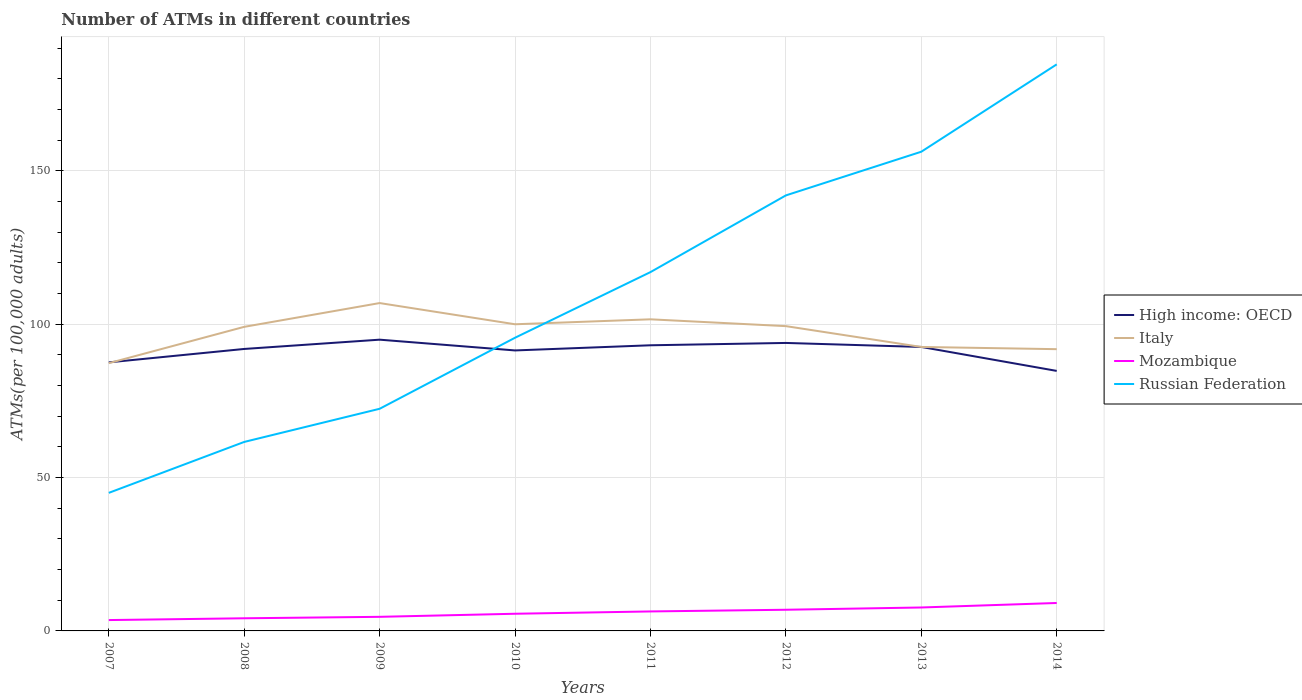Is the number of lines equal to the number of legend labels?
Offer a terse response. Yes. Across all years, what is the maximum number of ATMs in Mozambique?
Provide a succinct answer. 3.54. What is the total number of ATMs in High income: OECD in the graph?
Your response must be concise. 3.51. What is the difference between the highest and the second highest number of ATMs in High income: OECD?
Provide a succinct answer. 10.18. How many lines are there?
Provide a succinct answer. 4. How many years are there in the graph?
Provide a short and direct response. 8. What is the difference between two consecutive major ticks on the Y-axis?
Offer a terse response. 50. Does the graph contain any zero values?
Ensure brevity in your answer.  No. How are the legend labels stacked?
Offer a very short reply. Vertical. What is the title of the graph?
Make the answer very short. Number of ATMs in different countries. Does "Andorra" appear as one of the legend labels in the graph?
Provide a short and direct response. No. What is the label or title of the Y-axis?
Provide a short and direct response. ATMs(per 100,0 adults). What is the ATMs(per 100,000 adults) in High income: OECD in 2007?
Provide a short and direct response. 87.55. What is the ATMs(per 100,000 adults) in Italy in 2007?
Provide a short and direct response. 87.29. What is the ATMs(per 100,000 adults) in Mozambique in 2007?
Keep it short and to the point. 3.54. What is the ATMs(per 100,000 adults) in Russian Federation in 2007?
Provide a short and direct response. 45.01. What is the ATMs(per 100,000 adults) of High income: OECD in 2008?
Give a very brief answer. 91.92. What is the ATMs(per 100,000 adults) of Italy in 2008?
Ensure brevity in your answer.  99.13. What is the ATMs(per 100,000 adults) in Mozambique in 2008?
Your answer should be compact. 4.12. What is the ATMs(per 100,000 adults) of Russian Federation in 2008?
Keep it short and to the point. 61.61. What is the ATMs(per 100,000 adults) in High income: OECD in 2009?
Your response must be concise. 94.95. What is the ATMs(per 100,000 adults) in Italy in 2009?
Offer a very short reply. 106.88. What is the ATMs(per 100,000 adults) in Mozambique in 2009?
Make the answer very short. 4.59. What is the ATMs(per 100,000 adults) in Russian Federation in 2009?
Make the answer very short. 72.42. What is the ATMs(per 100,000 adults) of High income: OECD in 2010?
Your answer should be very brief. 91.44. What is the ATMs(per 100,000 adults) of Italy in 2010?
Keep it short and to the point. 99.97. What is the ATMs(per 100,000 adults) of Mozambique in 2010?
Offer a very short reply. 5.6. What is the ATMs(per 100,000 adults) of Russian Federation in 2010?
Keep it short and to the point. 95.58. What is the ATMs(per 100,000 adults) of High income: OECD in 2011?
Ensure brevity in your answer.  93.12. What is the ATMs(per 100,000 adults) of Italy in 2011?
Your answer should be compact. 101.58. What is the ATMs(per 100,000 adults) in Mozambique in 2011?
Your answer should be very brief. 6.35. What is the ATMs(per 100,000 adults) of Russian Federation in 2011?
Offer a terse response. 116.98. What is the ATMs(per 100,000 adults) in High income: OECD in 2012?
Provide a short and direct response. 93.88. What is the ATMs(per 100,000 adults) of Italy in 2012?
Keep it short and to the point. 99.36. What is the ATMs(per 100,000 adults) of Mozambique in 2012?
Offer a very short reply. 6.9. What is the ATMs(per 100,000 adults) in Russian Federation in 2012?
Make the answer very short. 141.98. What is the ATMs(per 100,000 adults) of High income: OECD in 2013?
Offer a very short reply. 92.57. What is the ATMs(per 100,000 adults) of Italy in 2013?
Make the answer very short. 92.57. What is the ATMs(per 100,000 adults) of Mozambique in 2013?
Offer a very short reply. 7.64. What is the ATMs(per 100,000 adults) in Russian Federation in 2013?
Give a very brief answer. 156.22. What is the ATMs(per 100,000 adults) of High income: OECD in 2014?
Your response must be concise. 84.77. What is the ATMs(per 100,000 adults) of Italy in 2014?
Your response must be concise. 91.85. What is the ATMs(per 100,000 adults) in Mozambique in 2014?
Your response must be concise. 9.11. What is the ATMs(per 100,000 adults) in Russian Federation in 2014?
Offer a very short reply. 184.7. Across all years, what is the maximum ATMs(per 100,000 adults) in High income: OECD?
Ensure brevity in your answer.  94.95. Across all years, what is the maximum ATMs(per 100,000 adults) of Italy?
Your answer should be compact. 106.88. Across all years, what is the maximum ATMs(per 100,000 adults) of Mozambique?
Give a very brief answer. 9.11. Across all years, what is the maximum ATMs(per 100,000 adults) of Russian Federation?
Your answer should be very brief. 184.7. Across all years, what is the minimum ATMs(per 100,000 adults) of High income: OECD?
Keep it short and to the point. 84.77. Across all years, what is the minimum ATMs(per 100,000 adults) in Italy?
Offer a very short reply. 87.29. Across all years, what is the minimum ATMs(per 100,000 adults) in Mozambique?
Ensure brevity in your answer.  3.54. Across all years, what is the minimum ATMs(per 100,000 adults) in Russian Federation?
Provide a succinct answer. 45.01. What is the total ATMs(per 100,000 adults) in High income: OECD in the graph?
Your answer should be very brief. 730.19. What is the total ATMs(per 100,000 adults) in Italy in the graph?
Provide a short and direct response. 778.64. What is the total ATMs(per 100,000 adults) of Mozambique in the graph?
Provide a succinct answer. 47.85. What is the total ATMs(per 100,000 adults) in Russian Federation in the graph?
Your answer should be compact. 874.48. What is the difference between the ATMs(per 100,000 adults) of High income: OECD in 2007 and that in 2008?
Offer a terse response. -4.37. What is the difference between the ATMs(per 100,000 adults) in Italy in 2007 and that in 2008?
Provide a short and direct response. -11.84. What is the difference between the ATMs(per 100,000 adults) of Mozambique in 2007 and that in 2008?
Provide a succinct answer. -0.58. What is the difference between the ATMs(per 100,000 adults) in Russian Federation in 2007 and that in 2008?
Keep it short and to the point. -16.61. What is the difference between the ATMs(per 100,000 adults) in High income: OECD in 2007 and that in 2009?
Provide a short and direct response. -7.4. What is the difference between the ATMs(per 100,000 adults) of Italy in 2007 and that in 2009?
Ensure brevity in your answer.  -19.59. What is the difference between the ATMs(per 100,000 adults) in Mozambique in 2007 and that in 2009?
Keep it short and to the point. -1.05. What is the difference between the ATMs(per 100,000 adults) of Russian Federation in 2007 and that in 2009?
Provide a succinct answer. -27.41. What is the difference between the ATMs(per 100,000 adults) in High income: OECD in 2007 and that in 2010?
Your response must be concise. -3.89. What is the difference between the ATMs(per 100,000 adults) in Italy in 2007 and that in 2010?
Your answer should be compact. -12.68. What is the difference between the ATMs(per 100,000 adults) in Mozambique in 2007 and that in 2010?
Offer a very short reply. -2.06. What is the difference between the ATMs(per 100,000 adults) of Russian Federation in 2007 and that in 2010?
Keep it short and to the point. -50.57. What is the difference between the ATMs(per 100,000 adults) in High income: OECD in 2007 and that in 2011?
Give a very brief answer. -5.57. What is the difference between the ATMs(per 100,000 adults) in Italy in 2007 and that in 2011?
Your response must be concise. -14.29. What is the difference between the ATMs(per 100,000 adults) of Mozambique in 2007 and that in 2011?
Offer a very short reply. -2.81. What is the difference between the ATMs(per 100,000 adults) of Russian Federation in 2007 and that in 2011?
Provide a succinct answer. -71.97. What is the difference between the ATMs(per 100,000 adults) in High income: OECD in 2007 and that in 2012?
Give a very brief answer. -6.34. What is the difference between the ATMs(per 100,000 adults) in Italy in 2007 and that in 2012?
Provide a short and direct response. -12.07. What is the difference between the ATMs(per 100,000 adults) in Mozambique in 2007 and that in 2012?
Keep it short and to the point. -3.36. What is the difference between the ATMs(per 100,000 adults) of Russian Federation in 2007 and that in 2012?
Keep it short and to the point. -96.98. What is the difference between the ATMs(per 100,000 adults) of High income: OECD in 2007 and that in 2013?
Give a very brief answer. -5.03. What is the difference between the ATMs(per 100,000 adults) of Italy in 2007 and that in 2013?
Provide a succinct answer. -5.28. What is the difference between the ATMs(per 100,000 adults) of Mozambique in 2007 and that in 2013?
Offer a terse response. -4.1. What is the difference between the ATMs(per 100,000 adults) in Russian Federation in 2007 and that in 2013?
Keep it short and to the point. -111.21. What is the difference between the ATMs(per 100,000 adults) of High income: OECD in 2007 and that in 2014?
Give a very brief answer. 2.78. What is the difference between the ATMs(per 100,000 adults) of Italy in 2007 and that in 2014?
Provide a succinct answer. -4.56. What is the difference between the ATMs(per 100,000 adults) in Mozambique in 2007 and that in 2014?
Give a very brief answer. -5.57. What is the difference between the ATMs(per 100,000 adults) of Russian Federation in 2007 and that in 2014?
Your response must be concise. -139.69. What is the difference between the ATMs(per 100,000 adults) of High income: OECD in 2008 and that in 2009?
Your answer should be compact. -3.03. What is the difference between the ATMs(per 100,000 adults) of Italy in 2008 and that in 2009?
Make the answer very short. -7.75. What is the difference between the ATMs(per 100,000 adults) of Mozambique in 2008 and that in 2009?
Make the answer very short. -0.47. What is the difference between the ATMs(per 100,000 adults) in Russian Federation in 2008 and that in 2009?
Your response must be concise. -10.81. What is the difference between the ATMs(per 100,000 adults) of High income: OECD in 2008 and that in 2010?
Provide a short and direct response. 0.48. What is the difference between the ATMs(per 100,000 adults) of Italy in 2008 and that in 2010?
Make the answer very short. -0.84. What is the difference between the ATMs(per 100,000 adults) in Mozambique in 2008 and that in 2010?
Your response must be concise. -1.47. What is the difference between the ATMs(per 100,000 adults) in Russian Federation in 2008 and that in 2010?
Offer a terse response. -33.97. What is the difference between the ATMs(per 100,000 adults) in High income: OECD in 2008 and that in 2011?
Provide a short and direct response. -1.2. What is the difference between the ATMs(per 100,000 adults) of Italy in 2008 and that in 2011?
Offer a very short reply. -2.46. What is the difference between the ATMs(per 100,000 adults) of Mozambique in 2008 and that in 2011?
Your answer should be very brief. -2.23. What is the difference between the ATMs(per 100,000 adults) in Russian Federation in 2008 and that in 2011?
Provide a short and direct response. -55.36. What is the difference between the ATMs(per 100,000 adults) of High income: OECD in 2008 and that in 2012?
Keep it short and to the point. -1.96. What is the difference between the ATMs(per 100,000 adults) of Italy in 2008 and that in 2012?
Ensure brevity in your answer.  -0.23. What is the difference between the ATMs(per 100,000 adults) of Mozambique in 2008 and that in 2012?
Keep it short and to the point. -2.78. What is the difference between the ATMs(per 100,000 adults) in Russian Federation in 2008 and that in 2012?
Provide a short and direct response. -80.37. What is the difference between the ATMs(per 100,000 adults) in High income: OECD in 2008 and that in 2013?
Keep it short and to the point. -0.65. What is the difference between the ATMs(per 100,000 adults) in Italy in 2008 and that in 2013?
Your response must be concise. 6.55. What is the difference between the ATMs(per 100,000 adults) in Mozambique in 2008 and that in 2013?
Provide a succinct answer. -3.52. What is the difference between the ATMs(per 100,000 adults) in Russian Federation in 2008 and that in 2013?
Provide a succinct answer. -94.61. What is the difference between the ATMs(per 100,000 adults) in High income: OECD in 2008 and that in 2014?
Give a very brief answer. 7.16. What is the difference between the ATMs(per 100,000 adults) in Italy in 2008 and that in 2014?
Ensure brevity in your answer.  7.28. What is the difference between the ATMs(per 100,000 adults) in Mozambique in 2008 and that in 2014?
Give a very brief answer. -4.99. What is the difference between the ATMs(per 100,000 adults) in Russian Federation in 2008 and that in 2014?
Your response must be concise. -123.09. What is the difference between the ATMs(per 100,000 adults) of High income: OECD in 2009 and that in 2010?
Provide a succinct answer. 3.51. What is the difference between the ATMs(per 100,000 adults) of Italy in 2009 and that in 2010?
Your answer should be compact. 6.91. What is the difference between the ATMs(per 100,000 adults) in Mozambique in 2009 and that in 2010?
Provide a short and direct response. -1. What is the difference between the ATMs(per 100,000 adults) of Russian Federation in 2009 and that in 2010?
Provide a succinct answer. -23.16. What is the difference between the ATMs(per 100,000 adults) in High income: OECD in 2009 and that in 2011?
Ensure brevity in your answer.  1.83. What is the difference between the ATMs(per 100,000 adults) in Italy in 2009 and that in 2011?
Ensure brevity in your answer.  5.3. What is the difference between the ATMs(per 100,000 adults) of Mozambique in 2009 and that in 2011?
Ensure brevity in your answer.  -1.76. What is the difference between the ATMs(per 100,000 adults) of Russian Federation in 2009 and that in 2011?
Offer a very short reply. -44.56. What is the difference between the ATMs(per 100,000 adults) of High income: OECD in 2009 and that in 2012?
Give a very brief answer. 1.06. What is the difference between the ATMs(per 100,000 adults) in Italy in 2009 and that in 2012?
Your answer should be very brief. 7.52. What is the difference between the ATMs(per 100,000 adults) in Mozambique in 2009 and that in 2012?
Keep it short and to the point. -2.31. What is the difference between the ATMs(per 100,000 adults) in Russian Federation in 2009 and that in 2012?
Keep it short and to the point. -69.56. What is the difference between the ATMs(per 100,000 adults) of High income: OECD in 2009 and that in 2013?
Make the answer very short. 2.37. What is the difference between the ATMs(per 100,000 adults) of Italy in 2009 and that in 2013?
Your answer should be compact. 14.31. What is the difference between the ATMs(per 100,000 adults) in Mozambique in 2009 and that in 2013?
Your answer should be very brief. -3.05. What is the difference between the ATMs(per 100,000 adults) in Russian Federation in 2009 and that in 2013?
Provide a short and direct response. -83.8. What is the difference between the ATMs(per 100,000 adults) of High income: OECD in 2009 and that in 2014?
Your answer should be very brief. 10.18. What is the difference between the ATMs(per 100,000 adults) of Italy in 2009 and that in 2014?
Provide a succinct answer. 15.03. What is the difference between the ATMs(per 100,000 adults) of Mozambique in 2009 and that in 2014?
Keep it short and to the point. -4.51. What is the difference between the ATMs(per 100,000 adults) in Russian Federation in 2009 and that in 2014?
Offer a very short reply. -112.28. What is the difference between the ATMs(per 100,000 adults) of High income: OECD in 2010 and that in 2011?
Your answer should be compact. -1.68. What is the difference between the ATMs(per 100,000 adults) in Italy in 2010 and that in 2011?
Give a very brief answer. -1.62. What is the difference between the ATMs(per 100,000 adults) in Mozambique in 2010 and that in 2011?
Make the answer very short. -0.76. What is the difference between the ATMs(per 100,000 adults) of Russian Federation in 2010 and that in 2011?
Offer a very short reply. -21.4. What is the difference between the ATMs(per 100,000 adults) of High income: OECD in 2010 and that in 2012?
Make the answer very short. -2.45. What is the difference between the ATMs(per 100,000 adults) in Italy in 2010 and that in 2012?
Provide a short and direct response. 0.61. What is the difference between the ATMs(per 100,000 adults) in Mozambique in 2010 and that in 2012?
Your answer should be very brief. -1.31. What is the difference between the ATMs(per 100,000 adults) of Russian Federation in 2010 and that in 2012?
Keep it short and to the point. -46.4. What is the difference between the ATMs(per 100,000 adults) of High income: OECD in 2010 and that in 2013?
Ensure brevity in your answer.  -1.14. What is the difference between the ATMs(per 100,000 adults) of Italy in 2010 and that in 2013?
Make the answer very short. 7.39. What is the difference between the ATMs(per 100,000 adults) in Mozambique in 2010 and that in 2013?
Your answer should be very brief. -2.04. What is the difference between the ATMs(per 100,000 adults) of Russian Federation in 2010 and that in 2013?
Your answer should be very brief. -60.64. What is the difference between the ATMs(per 100,000 adults) of High income: OECD in 2010 and that in 2014?
Offer a terse response. 6.67. What is the difference between the ATMs(per 100,000 adults) in Italy in 2010 and that in 2014?
Give a very brief answer. 8.12. What is the difference between the ATMs(per 100,000 adults) of Mozambique in 2010 and that in 2014?
Give a very brief answer. -3.51. What is the difference between the ATMs(per 100,000 adults) in Russian Federation in 2010 and that in 2014?
Your answer should be very brief. -89.12. What is the difference between the ATMs(per 100,000 adults) of High income: OECD in 2011 and that in 2012?
Your answer should be compact. -0.77. What is the difference between the ATMs(per 100,000 adults) in Italy in 2011 and that in 2012?
Provide a succinct answer. 2.23. What is the difference between the ATMs(per 100,000 adults) in Mozambique in 2011 and that in 2012?
Make the answer very short. -0.55. What is the difference between the ATMs(per 100,000 adults) in Russian Federation in 2011 and that in 2012?
Your answer should be very brief. -25.01. What is the difference between the ATMs(per 100,000 adults) in High income: OECD in 2011 and that in 2013?
Ensure brevity in your answer.  0.54. What is the difference between the ATMs(per 100,000 adults) of Italy in 2011 and that in 2013?
Keep it short and to the point. 9.01. What is the difference between the ATMs(per 100,000 adults) in Mozambique in 2011 and that in 2013?
Ensure brevity in your answer.  -1.29. What is the difference between the ATMs(per 100,000 adults) of Russian Federation in 2011 and that in 2013?
Your answer should be very brief. -39.24. What is the difference between the ATMs(per 100,000 adults) in High income: OECD in 2011 and that in 2014?
Your response must be concise. 8.35. What is the difference between the ATMs(per 100,000 adults) in Italy in 2011 and that in 2014?
Provide a succinct answer. 9.73. What is the difference between the ATMs(per 100,000 adults) of Mozambique in 2011 and that in 2014?
Provide a short and direct response. -2.75. What is the difference between the ATMs(per 100,000 adults) in Russian Federation in 2011 and that in 2014?
Ensure brevity in your answer.  -67.72. What is the difference between the ATMs(per 100,000 adults) of High income: OECD in 2012 and that in 2013?
Provide a short and direct response. 1.31. What is the difference between the ATMs(per 100,000 adults) in Italy in 2012 and that in 2013?
Give a very brief answer. 6.79. What is the difference between the ATMs(per 100,000 adults) in Mozambique in 2012 and that in 2013?
Give a very brief answer. -0.74. What is the difference between the ATMs(per 100,000 adults) of Russian Federation in 2012 and that in 2013?
Make the answer very short. -14.24. What is the difference between the ATMs(per 100,000 adults) in High income: OECD in 2012 and that in 2014?
Your answer should be very brief. 9.12. What is the difference between the ATMs(per 100,000 adults) of Italy in 2012 and that in 2014?
Offer a very short reply. 7.51. What is the difference between the ATMs(per 100,000 adults) of Mozambique in 2012 and that in 2014?
Provide a short and direct response. -2.21. What is the difference between the ATMs(per 100,000 adults) of Russian Federation in 2012 and that in 2014?
Keep it short and to the point. -42.72. What is the difference between the ATMs(per 100,000 adults) in High income: OECD in 2013 and that in 2014?
Your answer should be compact. 7.81. What is the difference between the ATMs(per 100,000 adults) in Italy in 2013 and that in 2014?
Your answer should be very brief. 0.72. What is the difference between the ATMs(per 100,000 adults) of Mozambique in 2013 and that in 2014?
Provide a succinct answer. -1.47. What is the difference between the ATMs(per 100,000 adults) of Russian Federation in 2013 and that in 2014?
Your response must be concise. -28.48. What is the difference between the ATMs(per 100,000 adults) of High income: OECD in 2007 and the ATMs(per 100,000 adults) of Italy in 2008?
Your answer should be compact. -11.58. What is the difference between the ATMs(per 100,000 adults) of High income: OECD in 2007 and the ATMs(per 100,000 adults) of Mozambique in 2008?
Your answer should be very brief. 83.43. What is the difference between the ATMs(per 100,000 adults) in High income: OECD in 2007 and the ATMs(per 100,000 adults) in Russian Federation in 2008?
Provide a short and direct response. 25.94. What is the difference between the ATMs(per 100,000 adults) in Italy in 2007 and the ATMs(per 100,000 adults) in Mozambique in 2008?
Provide a short and direct response. 83.17. What is the difference between the ATMs(per 100,000 adults) in Italy in 2007 and the ATMs(per 100,000 adults) in Russian Federation in 2008?
Provide a short and direct response. 25.68. What is the difference between the ATMs(per 100,000 adults) in Mozambique in 2007 and the ATMs(per 100,000 adults) in Russian Federation in 2008?
Your response must be concise. -58.07. What is the difference between the ATMs(per 100,000 adults) in High income: OECD in 2007 and the ATMs(per 100,000 adults) in Italy in 2009?
Offer a very short reply. -19.33. What is the difference between the ATMs(per 100,000 adults) of High income: OECD in 2007 and the ATMs(per 100,000 adults) of Mozambique in 2009?
Your response must be concise. 82.96. What is the difference between the ATMs(per 100,000 adults) of High income: OECD in 2007 and the ATMs(per 100,000 adults) of Russian Federation in 2009?
Provide a short and direct response. 15.13. What is the difference between the ATMs(per 100,000 adults) in Italy in 2007 and the ATMs(per 100,000 adults) in Mozambique in 2009?
Provide a succinct answer. 82.7. What is the difference between the ATMs(per 100,000 adults) of Italy in 2007 and the ATMs(per 100,000 adults) of Russian Federation in 2009?
Provide a succinct answer. 14.87. What is the difference between the ATMs(per 100,000 adults) in Mozambique in 2007 and the ATMs(per 100,000 adults) in Russian Federation in 2009?
Offer a very short reply. -68.88. What is the difference between the ATMs(per 100,000 adults) in High income: OECD in 2007 and the ATMs(per 100,000 adults) in Italy in 2010?
Give a very brief answer. -12.42. What is the difference between the ATMs(per 100,000 adults) of High income: OECD in 2007 and the ATMs(per 100,000 adults) of Mozambique in 2010?
Make the answer very short. 81.95. What is the difference between the ATMs(per 100,000 adults) in High income: OECD in 2007 and the ATMs(per 100,000 adults) in Russian Federation in 2010?
Ensure brevity in your answer.  -8.03. What is the difference between the ATMs(per 100,000 adults) in Italy in 2007 and the ATMs(per 100,000 adults) in Mozambique in 2010?
Provide a short and direct response. 81.69. What is the difference between the ATMs(per 100,000 adults) in Italy in 2007 and the ATMs(per 100,000 adults) in Russian Federation in 2010?
Ensure brevity in your answer.  -8.29. What is the difference between the ATMs(per 100,000 adults) of Mozambique in 2007 and the ATMs(per 100,000 adults) of Russian Federation in 2010?
Your response must be concise. -92.04. What is the difference between the ATMs(per 100,000 adults) of High income: OECD in 2007 and the ATMs(per 100,000 adults) of Italy in 2011?
Your answer should be very brief. -14.04. What is the difference between the ATMs(per 100,000 adults) in High income: OECD in 2007 and the ATMs(per 100,000 adults) in Mozambique in 2011?
Ensure brevity in your answer.  81.2. What is the difference between the ATMs(per 100,000 adults) of High income: OECD in 2007 and the ATMs(per 100,000 adults) of Russian Federation in 2011?
Keep it short and to the point. -29.43. What is the difference between the ATMs(per 100,000 adults) of Italy in 2007 and the ATMs(per 100,000 adults) of Mozambique in 2011?
Your answer should be compact. 80.94. What is the difference between the ATMs(per 100,000 adults) of Italy in 2007 and the ATMs(per 100,000 adults) of Russian Federation in 2011?
Your response must be concise. -29.69. What is the difference between the ATMs(per 100,000 adults) of Mozambique in 2007 and the ATMs(per 100,000 adults) of Russian Federation in 2011?
Provide a succinct answer. -113.44. What is the difference between the ATMs(per 100,000 adults) in High income: OECD in 2007 and the ATMs(per 100,000 adults) in Italy in 2012?
Offer a very short reply. -11.81. What is the difference between the ATMs(per 100,000 adults) in High income: OECD in 2007 and the ATMs(per 100,000 adults) in Mozambique in 2012?
Your response must be concise. 80.65. What is the difference between the ATMs(per 100,000 adults) of High income: OECD in 2007 and the ATMs(per 100,000 adults) of Russian Federation in 2012?
Keep it short and to the point. -54.43. What is the difference between the ATMs(per 100,000 adults) in Italy in 2007 and the ATMs(per 100,000 adults) in Mozambique in 2012?
Provide a succinct answer. 80.39. What is the difference between the ATMs(per 100,000 adults) in Italy in 2007 and the ATMs(per 100,000 adults) in Russian Federation in 2012?
Provide a short and direct response. -54.69. What is the difference between the ATMs(per 100,000 adults) in Mozambique in 2007 and the ATMs(per 100,000 adults) in Russian Federation in 2012?
Your answer should be compact. -138.44. What is the difference between the ATMs(per 100,000 adults) in High income: OECD in 2007 and the ATMs(per 100,000 adults) in Italy in 2013?
Offer a very short reply. -5.03. What is the difference between the ATMs(per 100,000 adults) in High income: OECD in 2007 and the ATMs(per 100,000 adults) in Mozambique in 2013?
Provide a short and direct response. 79.91. What is the difference between the ATMs(per 100,000 adults) in High income: OECD in 2007 and the ATMs(per 100,000 adults) in Russian Federation in 2013?
Give a very brief answer. -68.67. What is the difference between the ATMs(per 100,000 adults) in Italy in 2007 and the ATMs(per 100,000 adults) in Mozambique in 2013?
Your answer should be compact. 79.65. What is the difference between the ATMs(per 100,000 adults) in Italy in 2007 and the ATMs(per 100,000 adults) in Russian Federation in 2013?
Your response must be concise. -68.93. What is the difference between the ATMs(per 100,000 adults) in Mozambique in 2007 and the ATMs(per 100,000 adults) in Russian Federation in 2013?
Make the answer very short. -152.68. What is the difference between the ATMs(per 100,000 adults) of High income: OECD in 2007 and the ATMs(per 100,000 adults) of Italy in 2014?
Offer a terse response. -4.3. What is the difference between the ATMs(per 100,000 adults) of High income: OECD in 2007 and the ATMs(per 100,000 adults) of Mozambique in 2014?
Your answer should be very brief. 78.44. What is the difference between the ATMs(per 100,000 adults) of High income: OECD in 2007 and the ATMs(per 100,000 adults) of Russian Federation in 2014?
Provide a succinct answer. -97.15. What is the difference between the ATMs(per 100,000 adults) of Italy in 2007 and the ATMs(per 100,000 adults) of Mozambique in 2014?
Make the answer very short. 78.18. What is the difference between the ATMs(per 100,000 adults) of Italy in 2007 and the ATMs(per 100,000 adults) of Russian Federation in 2014?
Ensure brevity in your answer.  -97.41. What is the difference between the ATMs(per 100,000 adults) of Mozambique in 2007 and the ATMs(per 100,000 adults) of Russian Federation in 2014?
Ensure brevity in your answer.  -181.16. What is the difference between the ATMs(per 100,000 adults) in High income: OECD in 2008 and the ATMs(per 100,000 adults) in Italy in 2009?
Provide a succinct answer. -14.96. What is the difference between the ATMs(per 100,000 adults) in High income: OECD in 2008 and the ATMs(per 100,000 adults) in Mozambique in 2009?
Your response must be concise. 87.33. What is the difference between the ATMs(per 100,000 adults) in High income: OECD in 2008 and the ATMs(per 100,000 adults) in Russian Federation in 2009?
Offer a terse response. 19.5. What is the difference between the ATMs(per 100,000 adults) of Italy in 2008 and the ATMs(per 100,000 adults) of Mozambique in 2009?
Provide a succinct answer. 94.54. What is the difference between the ATMs(per 100,000 adults) in Italy in 2008 and the ATMs(per 100,000 adults) in Russian Federation in 2009?
Provide a succinct answer. 26.71. What is the difference between the ATMs(per 100,000 adults) of Mozambique in 2008 and the ATMs(per 100,000 adults) of Russian Federation in 2009?
Ensure brevity in your answer.  -68.3. What is the difference between the ATMs(per 100,000 adults) in High income: OECD in 2008 and the ATMs(per 100,000 adults) in Italy in 2010?
Your answer should be compact. -8.05. What is the difference between the ATMs(per 100,000 adults) of High income: OECD in 2008 and the ATMs(per 100,000 adults) of Mozambique in 2010?
Your answer should be compact. 86.33. What is the difference between the ATMs(per 100,000 adults) in High income: OECD in 2008 and the ATMs(per 100,000 adults) in Russian Federation in 2010?
Your response must be concise. -3.66. What is the difference between the ATMs(per 100,000 adults) in Italy in 2008 and the ATMs(per 100,000 adults) in Mozambique in 2010?
Offer a very short reply. 93.53. What is the difference between the ATMs(per 100,000 adults) of Italy in 2008 and the ATMs(per 100,000 adults) of Russian Federation in 2010?
Offer a terse response. 3.55. What is the difference between the ATMs(per 100,000 adults) in Mozambique in 2008 and the ATMs(per 100,000 adults) in Russian Federation in 2010?
Your response must be concise. -91.46. What is the difference between the ATMs(per 100,000 adults) of High income: OECD in 2008 and the ATMs(per 100,000 adults) of Italy in 2011?
Make the answer very short. -9.66. What is the difference between the ATMs(per 100,000 adults) in High income: OECD in 2008 and the ATMs(per 100,000 adults) in Mozambique in 2011?
Your answer should be compact. 85.57. What is the difference between the ATMs(per 100,000 adults) of High income: OECD in 2008 and the ATMs(per 100,000 adults) of Russian Federation in 2011?
Your response must be concise. -25.06. What is the difference between the ATMs(per 100,000 adults) of Italy in 2008 and the ATMs(per 100,000 adults) of Mozambique in 2011?
Give a very brief answer. 92.78. What is the difference between the ATMs(per 100,000 adults) in Italy in 2008 and the ATMs(per 100,000 adults) in Russian Federation in 2011?
Make the answer very short. -17.85. What is the difference between the ATMs(per 100,000 adults) in Mozambique in 2008 and the ATMs(per 100,000 adults) in Russian Federation in 2011?
Provide a succinct answer. -112.86. What is the difference between the ATMs(per 100,000 adults) of High income: OECD in 2008 and the ATMs(per 100,000 adults) of Italy in 2012?
Offer a terse response. -7.44. What is the difference between the ATMs(per 100,000 adults) in High income: OECD in 2008 and the ATMs(per 100,000 adults) in Mozambique in 2012?
Ensure brevity in your answer.  85.02. What is the difference between the ATMs(per 100,000 adults) of High income: OECD in 2008 and the ATMs(per 100,000 adults) of Russian Federation in 2012?
Offer a very short reply. -50.06. What is the difference between the ATMs(per 100,000 adults) of Italy in 2008 and the ATMs(per 100,000 adults) of Mozambique in 2012?
Provide a short and direct response. 92.23. What is the difference between the ATMs(per 100,000 adults) in Italy in 2008 and the ATMs(per 100,000 adults) in Russian Federation in 2012?
Offer a very short reply. -42.85. What is the difference between the ATMs(per 100,000 adults) of Mozambique in 2008 and the ATMs(per 100,000 adults) of Russian Federation in 2012?
Your response must be concise. -137.86. What is the difference between the ATMs(per 100,000 adults) in High income: OECD in 2008 and the ATMs(per 100,000 adults) in Italy in 2013?
Offer a very short reply. -0.65. What is the difference between the ATMs(per 100,000 adults) in High income: OECD in 2008 and the ATMs(per 100,000 adults) in Mozambique in 2013?
Provide a short and direct response. 84.28. What is the difference between the ATMs(per 100,000 adults) of High income: OECD in 2008 and the ATMs(per 100,000 adults) of Russian Federation in 2013?
Your response must be concise. -64.3. What is the difference between the ATMs(per 100,000 adults) in Italy in 2008 and the ATMs(per 100,000 adults) in Mozambique in 2013?
Ensure brevity in your answer.  91.49. What is the difference between the ATMs(per 100,000 adults) of Italy in 2008 and the ATMs(per 100,000 adults) of Russian Federation in 2013?
Give a very brief answer. -57.09. What is the difference between the ATMs(per 100,000 adults) of Mozambique in 2008 and the ATMs(per 100,000 adults) of Russian Federation in 2013?
Offer a terse response. -152.1. What is the difference between the ATMs(per 100,000 adults) in High income: OECD in 2008 and the ATMs(per 100,000 adults) in Italy in 2014?
Provide a short and direct response. 0.07. What is the difference between the ATMs(per 100,000 adults) in High income: OECD in 2008 and the ATMs(per 100,000 adults) in Mozambique in 2014?
Your answer should be very brief. 82.81. What is the difference between the ATMs(per 100,000 adults) of High income: OECD in 2008 and the ATMs(per 100,000 adults) of Russian Federation in 2014?
Your answer should be compact. -92.78. What is the difference between the ATMs(per 100,000 adults) of Italy in 2008 and the ATMs(per 100,000 adults) of Mozambique in 2014?
Your answer should be compact. 90.02. What is the difference between the ATMs(per 100,000 adults) of Italy in 2008 and the ATMs(per 100,000 adults) of Russian Federation in 2014?
Give a very brief answer. -85.57. What is the difference between the ATMs(per 100,000 adults) in Mozambique in 2008 and the ATMs(per 100,000 adults) in Russian Federation in 2014?
Provide a succinct answer. -180.58. What is the difference between the ATMs(per 100,000 adults) in High income: OECD in 2009 and the ATMs(per 100,000 adults) in Italy in 2010?
Provide a short and direct response. -5.02. What is the difference between the ATMs(per 100,000 adults) in High income: OECD in 2009 and the ATMs(per 100,000 adults) in Mozambique in 2010?
Offer a very short reply. 89.35. What is the difference between the ATMs(per 100,000 adults) in High income: OECD in 2009 and the ATMs(per 100,000 adults) in Russian Federation in 2010?
Offer a terse response. -0.63. What is the difference between the ATMs(per 100,000 adults) of Italy in 2009 and the ATMs(per 100,000 adults) of Mozambique in 2010?
Give a very brief answer. 101.28. What is the difference between the ATMs(per 100,000 adults) in Italy in 2009 and the ATMs(per 100,000 adults) in Russian Federation in 2010?
Provide a short and direct response. 11.3. What is the difference between the ATMs(per 100,000 adults) in Mozambique in 2009 and the ATMs(per 100,000 adults) in Russian Federation in 2010?
Provide a short and direct response. -90.99. What is the difference between the ATMs(per 100,000 adults) in High income: OECD in 2009 and the ATMs(per 100,000 adults) in Italy in 2011?
Ensure brevity in your answer.  -6.64. What is the difference between the ATMs(per 100,000 adults) of High income: OECD in 2009 and the ATMs(per 100,000 adults) of Mozambique in 2011?
Offer a terse response. 88.59. What is the difference between the ATMs(per 100,000 adults) of High income: OECD in 2009 and the ATMs(per 100,000 adults) of Russian Federation in 2011?
Give a very brief answer. -22.03. What is the difference between the ATMs(per 100,000 adults) in Italy in 2009 and the ATMs(per 100,000 adults) in Mozambique in 2011?
Provide a succinct answer. 100.53. What is the difference between the ATMs(per 100,000 adults) in Italy in 2009 and the ATMs(per 100,000 adults) in Russian Federation in 2011?
Provide a short and direct response. -10.1. What is the difference between the ATMs(per 100,000 adults) in Mozambique in 2009 and the ATMs(per 100,000 adults) in Russian Federation in 2011?
Ensure brevity in your answer.  -112.38. What is the difference between the ATMs(per 100,000 adults) of High income: OECD in 2009 and the ATMs(per 100,000 adults) of Italy in 2012?
Make the answer very short. -4.41. What is the difference between the ATMs(per 100,000 adults) of High income: OECD in 2009 and the ATMs(per 100,000 adults) of Mozambique in 2012?
Your answer should be very brief. 88.04. What is the difference between the ATMs(per 100,000 adults) of High income: OECD in 2009 and the ATMs(per 100,000 adults) of Russian Federation in 2012?
Your response must be concise. -47.03. What is the difference between the ATMs(per 100,000 adults) in Italy in 2009 and the ATMs(per 100,000 adults) in Mozambique in 2012?
Make the answer very short. 99.98. What is the difference between the ATMs(per 100,000 adults) of Italy in 2009 and the ATMs(per 100,000 adults) of Russian Federation in 2012?
Your answer should be very brief. -35.1. What is the difference between the ATMs(per 100,000 adults) in Mozambique in 2009 and the ATMs(per 100,000 adults) in Russian Federation in 2012?
Keep it short and to the point. -137.39. What is the difference between the ATMs(per 100,000 adults) of High income: OECD in 2009 and the ATMs(per 100,000 adults) of Italy in 2013?
Provide a succinct answer. 2.37. What is the difference between the ATMs(per 100,000 adults) of High income: OECD in 2009 and the ATMs(per 100,000 adults) of Mozambique in 2013?
Offer a terse response. 87.31. What is the difference between the ATMs(per 100,000 adults) of High income: OECD in 2009 and the ATMs(per 100,000 adults) of Russian Federation in 2013?
Make the answer very short. -61.27. What is the difference between the ATMs(per 100,000 adults) in Italy in 2009 and the ATMs(per 100,000 adults) in Mozambique in 2013?
Provide a short and direct response. 99.24. What is the difference between the ATMs(per 100,000 adults) in Italy in 2009 and the ATMs(per 100,000 adults) in Russian Federation in 2013?
Offer a very short reply. -49.34. What is the difference between the ATMs(per 100,000 adults) of Mozambique in 2009 and the ATMs(per 100,000 adults) of Russian Federation in 2013?
Your answer should be compact. -151.63. What is the difference between the ATMs(per 100,000 adults) in High income: OECD in 2009 and the ATMs(per 100,000 adults) in Italy in 2014?
Provide a short and direct response. 3.1. What is the difference between the ATMs(per 100,000 adults) in High income: OECD in 2009 and the ATMs(per 100,000 adults) in Mozambique in 2014?
Make the answer very short. 85.84. What is the difference between the ATMs(per 100,000 adults) of High income: OECD in 2009 and the ATMs(per 100,000 adults) of Russian Federation in 2014?
Offer a very short reply. -89.75. What is the difference between the ATMs(per 100,000 adults) of Italy in 2009 and the ATMs(per 100,000 adults) of Mozambique in 2014?
Provide a short and direct response. 97.77. What is the difference between the ATMs(per 100,000 adults) of Italy in 2009 and the ATMs(per 100,000 adults) of Russian Federation in 2014?
Your answer should be compact. -77.82. What is the difference between the ATMs(per 100,000 adults) of Mozambique in 2009 and the ATMs(per 100,000 adults) of Russian Federation in 2014?
Offer a very short reply. -180.11. What is the difference between the ATMs(per 100,000 adults) of High income: OECD in 2010 and the ATMs(per 100,000 adults) of Italy in 2011?
Your answer should be compact. -10.15. What is the difference between the ATMs(per 100,000 adults) of High income: OECD in 2010 and the ATMs(per 100,000 adults) of Mozambique in 2011?
Your response must be concise. 85.08. What is the difference between the ATMs(per 100,000 adults) in High income: OECD in 2010 and the ATMs(per 100,000 adults) in Russian Federation in 2011?
Your response must be concise. -25.54. What is the difference between the ATMs(per 100,000 adults) in Italy in 2010 and the ATMs(per 100,000 adults) in Mozambique in 2011?
Your response must be concise. 93.62. What is the difference between the ATMs(per 100,000 adults) of Italy in 2010 and the ATMs(per 100,000 adults) of Russian Federation in 2011?
Offer a terse response. -17.01. What is the difference between the ATMs(per 100,000 adults) of Mozambique in 2010 and the ATMs(per 100,000 adults) of Russian Federation in 2011?
Offer a terse response. -111.38. What is the difference between the ATMs(per 100,000 adults) in High income: OECD in 2010 and the ATMs(per 100,000 adults) in Italy in 2012?
Make the answer very short. -7.92. What is the difference between the ATMs(per 100,000 adults) of High income: OECD in 2010 and the ATMs(per 100,000 adults) of Mozambique in 2012?
Offer a terse response. 84.54. What is the difference between the ATMs(per 100,000 adults) in High income: OECD in 2010 and the ATMs(per 100,000 adults) in Russian Federation in 2012?
Keep it short and to the point. -50.54. What is the difference between the ATMs(per 100,000 adults) in Italy in 2010 and the ATMs(per 100,000 adults) in Mozambique in 2012?
Keep it short and to the point. 93.07. What is the difference between the ATMs(per 100,000 adults) in Italy in 2010 and the ATMs(per 100,000 adults) in Russian Federation in 2012?
Provide a succinct answer. -42.01. What is the difference between the ATMs(per 100,000 adults) in Mozambique in 2010 and the ATMs(per 100,000 adults) in Russian Federation in 2012?
Ensure brevity in your answer.  -136.39. What is the difference between the ATMs(per 100,000 adults) of High income: OECD in 2010 and the ATMs(per 100,000 adults) of Italy in 2013?
Provide a succinct answer. -1.14. What is the difference between the ATMs(per 100,000 adults) of High income: OECD in 2010 and the ATMs(per 100,000 adults) of Mozambique in 2013?
Offer a very short reply. 83.8. What is the difference between the ATMs(per 100,000 adults) of High income: OECD in 2010 and the ATMs(per 100,000 adults) of Russian Federation in 2013?
Ensure brevity in your answer.  -64.78. What is the difference between the ATMs(per 100,000 adults) in Italy in 2010 and the ATMs(per 100,000 adults) in Mozambique in 2013?
Ensure brevity in your answer.  92.33. What is the difference between the ATMs(per 100,000 adults) of Italy in 2010 and the ATMs(per 100,000 adults) of Russian Federation in 2013?
Your answer should be very brief. -56.25. What is the difference between the ATMs(per 100,000 adults) in Mozambique in 2010 and the ATMs(per 100,000 adults) in Russian Federation in 2013?
Offer a terse response. -150.62. What is the difference between the ATMs(per 100,000 adults) in High income: OECD in 2010 and the ATMs(per 100,000 adults) in Italy in 2014?
Your response must be concise. -0.41. What is the difference between the ATMs(per 100,000 adults) of High income: OECD in 2010 and the ATMs(per 100,000 adults) of Mozambique in 2014?
Offer a terse response. 82.33. What is the difference between the ATMs(per 100,000 adults) of High income: OECD in 2010 and the ATMs(per 100,000 adults) of Russian Federation in 2014?
Ensure brevity in your answer.  -93.26. What is the difference between the ATMs(per 100,000 adults) of Italy in 2010 and the ATMs(per 100,000 adults) of Mozambique in 2014?
Provide a succinct answer. 90.86. What is the difference between the ATMs(per 100,000 adults) of Italy in 2010 and the ATMs(per 100,000 adults) of Russian Federation in 2014?
Provide a short and direct response. -84.73. What is the difference between the ATMs(per 100,000 adults) in Mozambique in 2010 and the ATMs(per 100,000 adults) in Russian Federation in 2014?
Your answer should be compact. -179.1. What is the difference between the ATMs(per 100,000 adults) in High income: OECD in 2011 and the ATMs(per 100,000 adults) in Italy in 2012?
Keep it short and to the point. -6.24. What is the difference between the ATMs(per 100,000 adults) in High income: OECD in 2011 and the ATMs(per 100,000 adults) in Mozambique in 2012?
Ensure brevity in your answer.  86.22. What is the difference between the ATMs(per 100,000 adults) in High income: OECD in 2011 and the ATMs(per 100,000 adults) in Russian Federation in 2012?
Your answer should be very brief. -48.86. What is the difference between the ATMs(per 100,000 adults) of Italy in 2011 and the ATMs(per 100,000 adults) of Mozambique in 2012?
Keep it short and to the point. 94.68. What is the difference between the ATMs(per 100,000 adults) in Italy in 2011 and the ATMs(per 100,000 adults) in Russian Federation in 2012?
Keep it short and to the point. -40.4. What is the difference between the ATMs(per 100,000 adults) of Mozambique in 2011 and the ATMs(per 100,000 adults) of Russian Federation in 2012?
Keep it short and to the point. -135.63. What is the difference between the ATMs(per 100,000 adults) of High income: OECD in 2011 and the ATMs(per 100,000 adults) of Italy in 2013?
Keep it short and to the point. 0.54. What is the difference between the ATMs(per 100,000 adults) in High income: OECD in 2011 and the ATMs(per 100,000 adults) in Mozambique in 2013?
Provide a succinct answer. 85.48. What is the difference between the ATMs(per 100,000 adults) of High income: OECD in 2011 and the ATMs(per 100,000 adults) of Russian Federation in 2013?
Offer a terse response. -63.1. What is the difference between the ATMs(per 100,000 adults) of Italy in 2011 and the ATMs(per 100,000 adults) of Mozambique in 2013?
Provide a short and direct response. 93.94. What is the difference between the ATMs(per 100,000 adults) in Italy in 2011 and the ATMs(per 100,000 adults) in Russian Federation in 2013?
Your answer should be compact. -54.63. What is the difference between the ATMs(per 100,000 adults) in Mozambique in 2011 and the ATMs(per 100,000 adults) in Russian Federation in 2013?
Offer a terse response. -149.87. What is the difference between the ATMs(per 100,000 adults) in High income: OECD in 2011 and the ATMs(per 100,000 adults) in Italy in 2014?
Provide a short and direct response. 1.27. What is the difference between the ATMs(per 100,000 adults) in High income: OECD in 2011 and the ATMs(per 100,000 adults) in Mozambique in 2014?
Your response must be concise. 84.01. What is the difference between the ATMs(per 100,000 adults) of High income: OECD in 2011 and the ATMs(per 100,000 adults) of Russian Federation in 2014?
Provide a succinct answer. -91.58. What is the difference between the ATMs(per 100,000 adults) of Italy in 2011 and the ATMs(per 100,000 adults) of Mozambique in 2014?
Your response must be concise. 92.48. What is the difference between the ATMs(per 100,000 adults) in Italy in 2011 and the ATMs(per 100,000 adults) in Russian Federation in 2014?
Keep it short and to the point. -83.11. What is the difference between the ATMs(per 100,000 adults) of Mozambique in 2011 and the ATMs(per 100,000 adults) of Russian Federation in 2014?
Ensure brevity in your answer.  -178.34. What is the difference between the ATMs(per 100,000 adults) in High income: OECD in 2012 and the ATMs(per 100,000 adults) in Italy in 2013?
Provide a succinct answer. 1.31. What is the difference between the ATMs(per 100,000 adults) in High income: OECD in 2012 and the ATMs(per 100,000 adults) in Mozambique in 2013?
Offer a very short reply. 86.24. What is the difference between the ATMs(per 100,000 adults) of High income: OECD in 2012 and the ATMs(per 100,000 adults) of Russian Federation in 2013?
Keep it short and to the point. -62.33. What is the difference between the ATMs(per 100,000 adults) of Italy in 2012 and the ATMs(per 100,000 adults) of Mozambique in 2013?
Ensure brevity in your answer.  91.72. What is the difference between the ATMs(per 100,000 adults) of Italy in 2012 and the ATMs(per 100,000 adults) of Russian Federation in 2013?
Give a very brief answer. -56.86. What is the difference between the ATMs(per 100,000 adults) of Mozambique in 2012 and the ATMs(per 100,000 adults) of Russian Federation in 2013?
Ensure brevity in your answer.  -149.32. What is the difference between the ATMs(per 100,000 adults) in High income: OECD in 2012 and the ATMs(per 100,000 adults) in Italy in 2014?
Give a very brief answer. 2.03. What is the difference between the ATMs(per 100,000 adults) of High income: OECD in 2012 and the ATMs(per 100,000 adults) of Mozambique in 2014?
Make the answer very short. 84.78. What is the difference between the ATMs(per 100,000 adults) of High income: OECD in 2012 and the ATMs(per 100,000 adults) of Russian Federation in 2014?
Your answer should be very brief. -90.81. What is the difference between the ATMs(per 100,000 adults) of Italy in 2012 and the ATMs(per 100,000 adults) of Mozambique in 2014?
Provide a short and direct response. 90.25. What is the difference between the ATMs(per 100,000 adults) of Italy in 2012 and the ATMs(per 100,000 adults) of Russian Federation in 2014?
Make the answer very short. -85.34. What is the difference between the ATMs(per 100,000 adults) of Mozambique in 2012 and the ATMs(per 100,000 adults) of Russian Federation in 2014?
Give a very brief answer. -177.8. What is the difference between the ATMs(per 100,000 adults) in High income: OECD in 2013 and the ATMs(per 100,000 adults) in Italy in 2014?
Offer a terse response. 0.72. What is the difference between the ATMs(per 100,000 adults) in High income: OECD in 2013 and the ATMs(per 100,000 adults) in Mozambique in 2014?
Offer a very short reply. 83.47. What is the difference between the ATMs(per 100,000 adults) in High income: OECD in 2013 and the ATMs(per 100,000 adults) in Russian Federation in 2014?
Provide a succinct answer. -92.12. What is the difference between the ATMs(per 100,000 adults) in Italy in 2013 and the ATMs(per 100,000 adults) in Mozambique in 2014?
Your response must be concise. 83.47. What is the difference between the ATMs(per 100,000 adults) of Italy in 2013 and the ATMs(per 100,000 adults) of Russian Federation in 2014?
Your answer should be compact. -92.12. What is the difference between the ATMs(per 100,000 adults) in Mozambique in 2013 and the ATMs(per 100,000 adults) in Russian Federation in 2014?
Keep it short and to the point. -177.06. What is the average ATMs(per 100,000 adults) in High income: OECD per year?
Offer a terse response. 91.27. What is the average ATMs(per 100,000 adults) of Italy per year?
Your answer should be compact. 97.33. What is the average ATMs(per 100,000 adults) in Mozambique per year?
Your answer should be very brief. 5.98. What is the average ATMs(per 100,000 adults) of Russian Federation per year?
Provide a succinct answer. 109.31. In the year 2007, what is the difference between the ATMs(per 100,000 adults) in High income: OECD and ATMs(per 100,000 adults) in Italy?
Your answer should be compact. 0.26. In the year 2007, what is the difference between the ATMs(per 100,000 adults) in High income: OECD and ATMs(per 100,000 adults) in Mozambique?
Keep it short and to the point. 84.01. In the year 2007, what is the difference between the ATMs(per 100,000 adults) of High income: OECD and ATMs(per 100,000 adults) of Russian Federation?
Provide a succinct answer. 42.54. In the year 2007, what is the difference between the ATMs(per 100,000 adults) in Italy and ATMs(per 100,000 adults) in Mozambique?
Provide a succinct answer. 83.75. In the year 2007, what is the difference between the ATMs(per 100,000 adults) of Italy and ATMs(per 100,000 adults) of Russian Federation?
Provide a succinct answer. 42.28. In the year 2007, what is the difference between the ATMs(per 100,000 adults) of Mozambique and ATMs(per 100,000 adults) of Russian Federation?
Make the answer very short. -41.47. In the year 2008, what is the difference between the ATMs(per 100,000 adults) of High income: OECD and ATMs(per 100,000 adults) of Italy?
Keep it short and to the point. -7.21. In the year 2008, what is the difference between the ATMs(per 100,000 adults) in High income: OECD and ATMs(per 100,000 adults) in Mozambique?
Provide a succinct answer. 87.8. In the year 2008, what is the difference between the ATMs(per 100,000 adults) of High income: OECD and ATMs(per 100,000 adults) of Russian Federation?
Make the answer very short. 30.31. In the year 2008, what is the difference between the ATMs(per 100,000 adults) of Italy and ATMs(per 100,000 adults) of Mozambique?
Offer a terse response. 95.01. In the year 2008, what is the difference between the ATMs(per 100,000 adults) of Italy and ATMs(per 100,000 adults) of Russian Federation?
Make the answer very short. 37.52. In the year 2008, what is the difference between the ATMs(per 100,000 adults) of Mozambique and ATMs(per 100,000 adults) of Russian Federation?
Offer a very short reply. -57.49. In the year 2009, what is the difference between the ATMs(per 100,000 adults) in High income: OECD and ATMs(per 100,000 adults) in Italy?
Make the answer very short. -11.93. In the year 2009, what is the difference between the ATMs(per 100,000 adults) of High income: OECD and ATMs(per 100,000 adults) of Mozambique?
Provide a succinct answer. 90.35. In the year 2009, what is the difference between the ATMs(per 100,000 adults) in High income: OECD and ATMs(per 100,000 adults) in Russian Federation?
Make the answer very short. 22.53. In the year 2009, what is the difference between the ATMs(per 100,000 adults) in Italy and ATMs(per 100,000 adults) in Mozambique?
Ensure brevity in your answer.  102.29. In the year 2009, what is the difference between the ATMs(per 100,000 adults) of Italy and ATMs(per 100,000 adults) of Russian Federation?
Offer a terse response. 34.46. In the year 2009, what is the difference between the ATMs(per 100,000 adults) of Mozambique and ATMs(per 100,000 adults) of Russian Federation?
Your response must be concise. -67.82. In the year 2010, what is the difference between the ATMs(per 100,000 adults) in High income: OECD and ATMs(per 100,000 adults) in Italy?
Give a very brief answer. -8.53. In the year 2010, what is the difference between the ATMs(per 100,000 adults) of High income: OECD and ATMs(per 100,000 adults) of Mozambique?
Keep it short and to the point. 85.84. In the year 2010, what is the difference between the ATMs(per 100,000 adults) of High income: OECD and ATMs(per 100,000 adults) of Russian Federation?
Keep it short and to the point. -4.14. In the year 2010, what is the difference between the ATMs(per 100,000 adults) in Italy and ATMs(per 100,000 adults) in Mozambique?
Keep it short and to the point. 94.37. In the year 2010, what is the difference between the ATMs(per 100,000 adults) in Italy and ATMs(per 100,000 adults) in Russian Federation?
Your answer should be compact. 4.39. In the year 2010, what is the difference between the ATMs(per 100,000 adults) of Mozambique and ATMs(per 100,000 adults) of Russian Federation?
Your answer should be very brief. -89.98. In the year 2011, what is the difference between the ATMs(per 100,000 adults) of High income: OECD and ATMs(per 100,000 adults) of Italy?
Provide a short and direct response. -8.47. In the year 2011, what is the difference between the ATMs(per 100,000 adults) in High income: OECD and ATMs(per 100,000 adults) in Mozambique?
Your response must be concise. 86.77. In the year 2011, what is the difference between the ATMs(per 100,000 adults) of High income: OECD and ATMs(per 100,000 adults) of Russian Federation?
Give a very brief answer. -23.86. In the year 2011, what is the difference between the ATMs(per 100,000 adults) of Italy and ATMs(per 100,000 adults) of Mozambique?
Keep it short and to the point. 95.23. In the year 2011, what is the difference between the ATMs(per 100,000 adults) in Italy and ATMs(per 100,000 adults) in Russian Federation?
Make the answer very short. -15.39. In the year 2011, what is the difference between the ATMs(per 100,000 adults) in Mozambique and ATMs(per 100,000 adults) in Russian Federation?
Give a very brief answer. -110.62. In the year 2012, what is the difference between the ATMs(per 100,000 adults) in High income: OECD and ATMs(per 100,000 adults) in Italy?
Offer a very short reply. -5.48. In the year 2012, what is the difference between the ATMs(per 100,000 adults) of High income: OECD and ATMs(per 100,000 adults) of Mozambique?
Provide a short and direct response. 86.98. In the year 2012, what is the difference between the ATMs(per 100,000 adults) in High income: OECD and ATMs(per 100,000 adults) in Russian Federation?
Ensure brevity in your answer.  -48.1. In the year 2012, what is the difference between the ATMs(per 100,000 adults) of Italy and ATMs(per 100,000 adults) of Mozambique?
Provide a succinct answer. 92.46. In the year 2012, what is the difference between the ATMs(per 100,000 adults) in Italy and ATMs(per 100,000 adults) in Russian Federation?
Make the answer very short. -42.62. In the year 2012, what is the difference between the ATMs(per 100,000 adults) in Mozambique and ATMs(per 100,000 adults) in Russian Federation?
Provide a short and direct response. -135.08. In the year 2013, what is the difference between the ATMs(per 100,000 adults) of High income: OECD and ATMs(per 100,000 adults) of Italy?
Ensure brevity in your answer.  0. In the year 2013, what is the difference between the ATMs(per 100,000 adults) in High income: OECD and ATMs(per 100,000 adults) in Mozambique?
Your answer should be very brief. 84.93. In the year 2013, what is the difference between the ATMs(per 100,000 adults) in High income: OECD and ATMs(per 100,000 adults) in Russian Federation?
Your response must be concise. -63.64. In the year 2013, what is the difference between the ATMs(per 100,000 adults) in Italy and ATMs(per 100,000 adults) in Mozambique?
Your response must be concise. 84.93. In the year 2013, what is the difference between the ATMs(per 100,000 adults) in Italy and ATMs(per 100,000 adults) in Russian Federation?
Your answer should be compact. -63.64. In the year 2013, what is the difference between the ATMs(per 100,000 adults) of Mozambique and ATMs(per 100,000 adults) of Russian Federation?
Give a very brief answer. -148.58. In the year 2014, what is the difference between the ATMs(per 100,000 adults) of High income: OECD and ATMs(per 100,000 adults) of Italy?
Offer a terse response. -7.09. In the year 2014, what is the difference between the ATMs(per 100,000 adults) of High income: OECD and ATMs(per 100,000 adults) of Mozambique?
Your answer should be very brief. 75.66. In the year 2014, what is the difference between the ATMs(per 100,000 adults) of High income: OECD and ATMs(per 100,000 adults) of Russian Federation?
Give a very brief answer. -99.93. In the year 2014, what is the difference between the ATMs(per 100,000 adults) of Italy and ATMs(per 100,000 adults) of Mozambique?
Offer a very short reply. 82.74. In the year 2014, what is the difference between the ATMs(per 100,000 adults) in Italy and ATMs(per 100,000 adults) in Russian Federation?
Provide a short and direct response. -92.85. In the year 2014, what is the difference between the ATMs(per 100,000 adults) of Mozambique and ATMs(per 100,000 adults) of Russian Federation?
Your answer should be very brief. -175.59. What is the ratio of the ATMs(per 100,000 adults) in Italy in 2007 to that in 2008?
Your answer should be very brief. 0.88. What is the ratio of the ATMs(per 100,000 adults) of Mozambique in 2007 to that in 2008?
Your response must be concise. 0.86. What is the ratio of the ATMs(per 100,000 adults) in Russian Federation in 2007 to that in 2008?
Offer a terse response. 0.73. What is the ratio of the ATMs(per 100,000 adults) of High income: OECD in 2007 to that in 2009?
Keep it short and to the point. 0.92. What is the ratio of the ATMs(per 100,000 adults) in Italy in 2007 to that in 2009?
Provide a short and direct response. 0.82. What is the ratio of the ATMs(per 100,000 adults) of Mozambique in 2007 to that in 2009?
Give a very brief answer. 0.77. What is the ratio of the ATMs(per 100,000 adults) of Russian Federation in 2007 to that in 2009?
Your answer should be very brief. 0.62. What is the ratio of the ATMs(per 100,000 adults) of High income: OECD in 2007 to that in 2010?
Provide a succinct answer. 0.96. What is the ratio of the ATMs(per 100,000 adults) in Italy in 2007 to that in 2010?
Provide a succinct answer. 0.87. What is the ratio of the ATMs(per 100,000 adults) of Mozambique in 2007 to that in 2010?
Give a very brief answer. 0.63. What is the ratio of the ATMs(per 100,000 adults) of Russian Federation in 2007 to that in 2010?
Provide a succinct answer. 0.47. What is the ratio of the ATMs(per 100,000 adults) in High income: OECD in 2007 to that in 2011?
Make the answer very short. 0.94. What is the ratio of the ATMs(per 100,000 adults) of Italy in 2007 to that in 2011?
Your answer should be compact. 0.86. What is the ratio of the ATMs(per 100,000 adults) of Mozambique in 2007 to that in 2011?
Make the answer very short. 0.56. What is the ratio of the ATMs(per 100,000 adults) in Russian Federation in 2007 to that in 2011?
Offer a very short reply. 0.38. What is the ratio of the ATMs(per 100,000 adults) of High income: OECD in 2007 to that in 2012?
Your answer should be compact. 0.93. What is the ratio of the ATMs(per 100,000 adults) of Italy in 2007 to that in 2012?
Keep it short and to the point. 0.88. What is the ratio of the ATMs(per 100,000 adults) in Mozambique in 2007 to that in 2012?
Provide a short and direct response. 0.51. What is the ratio of the ATMs(per 100,000 adults) in Russian Federation in 2007 to that in 2012?
Offer a terse response. 0.32. What is the ratio of the ATMs(per 100,000 adults) in High income: OECD in 2007 to that in 2013?
Give a very brief answer. 0.95. What is the ratio of the ATMs(per 100,000 adults) of Italy in 2007 to that in 2013?
Ensure brevity in your answer.  0.94. What is the ratio of the ATMs(per 100,000 adults) of Mozambique in 2007 to that in 2013?
Offer a very short reply. 0.46. What is the ratio of the ATMs(per 100,000 adults) of Russian Federation in 2007 to that in 2013?
Ensure brevity in your answer.  0.29. What is the ratio of the ATMs(per 100,000 adults) of High income: OECD in 2007 to that in 2014?
Your answer should be very brief. 1.03. What is the ratio of the ATMs(per 100,000 adults) of Italy in 2007 to that in 2014?
Keep it short and to the point. 0.95. What is the ratio of the ATMs(per 100,000 adults) of Mozambique in 2007 to that in 2014?
Offer a terse response. 0.39. What is the ratio of the ATMs(per 100,000 adults) of Russian Federation in 2007 to that in 2014?
Ensure brevity in your answer.  0.24. What is the ratio of the ATMs(per 100,000 adults) in High income: OECD in 2008 to that in 2009?
Offer a terse response. 0.97. What is the ratio of the ATMs(per 100,000 adults) in Italy in 2008 to that in 2009?
Give a very brief answer. 0.93. What is the ratio of the ATMs(per 100,000 adults) of Mozambique in 2008 to that in 2009?
Your answer should be compact. 0.9. What is the ratio of the ATMs(per 100,000 adults) in Russian Federation in 2008 to that in 2009?
Offer a terse response. 0.85. What is the ratio of the ATMs(per 100,000 adults) in Mozambique in 2008 to that in 2010?
Give a very brief answer. 0.74. What is the ratio of the ATMs(per 100,000 adults) in Russian Federation in 2008 to that in 2010?
Make the answer very short. 0.64. What is the ratio of the ATMs(per 100,000 adults) of High income: OECD in 2008 to that in 2011?
Offer a very short reply. 0.99. What is the ratio of the ATMs(per 100,000 adults) in Italy in 2008 to that in 2011?
Give a very brief answer. 0.98. What is the ratio of the ATMs(per 100,000 adults) in Mozambique in 2008 to that in 2011?
Ensure brevity in your answer.  0.65. What is the ratio of the ATMs(per 100,000 adults) of Russian Federation in 2008 to that in 2011?
Your response must be concise. 0.53. What is the ratio of the ATMs(per 100,000 adults) in High income: OECD in 2008 to that in 2012?
Ensure brevity in your answer.  0.98. What is the ratio of the ATMs(per 100,000 adults) of Italy in 2008 to that in 2012?
Provide a short and direct response. 1. What is the ratio of the ATMs(per 100,000 adults) of Mozambique in 2008 to that in 2012?
Provide a short and direct response. 0.6. What is the ratio of the ATMs(per 100,000 adults) of Russian Federation in 2008 to that in 2012?
Offer a terse response. 0.43. What is the ratio of the ATMs(per 100,000 adults) in High income: OECD in 2008 to that in 2013?
Provide a short and direct response. 0.99. What is the ratio of the ATMs(per 100,000 adults) in Italy in 2008 to that in 2013?
Your answer should be very brief. 1.07. What is the ratio of the ATMs(per 100,000 adults) of Mozambique in 2008 to that in 2013?
Keep it short and to the point. 0.54. What is the ratio of the ATMs(per 100,000 adults) in Russian Federation in 2008 to that in 2013?
Offer a terse response. 0.39. What is the ratio of the ATMs(per 100,000 adults) of High income: OECD in 2008 to that in 2014?
Give a very brief answer. 1.08. What is the ratio of the ATMs(per 100,000 adults) in Italy in 2008 to that in 2014?
Ensure brevity in your answer.  1.08. What is the ratio of the ATMs(per 100,000 adults) of Mozambique in 2008 to that in 2014?
Give a very brief answer. 0.45. What is the ratio of the ATMs(per 100,000 adults) in Russian Federation in 2008 to that in 2014?
Offer a terse response. 0.33. What is the ratio of the ATMs(per 100,000 adults) in High income: OECD in 2009 to that in 2010?
Provide a succinct answer. 1.04. What is the ratio of the ATMs(per 100,000 adults) of Italy in 2009 to that in 2010?
Provide a short and direct response. 1.07. What is the ratio of the ATMs(per 100,000 adults) of Mozambique in 2009 to that in 2010?
Offer a terse response. 0.82. What is the ratio of the ATMs(per 100,000 adults) of Russian Federation in 2009 to that in 2010?
Provide a short and direct response. 0.76. What is the ratio of the ATMs(per 100,000 adults) of High income: OECD in 2009 to that in 2011?
Your answer should be very brief. 1.02. What is the ratio of the ATMs(per 100,000 adults) of Italy in 2009 to that in 2011?
Provide a succinct answer. 1.05. What is the ratio of the ATMs(per 100,000 adults) of Mozambique in 2009 to that in 2011?
Your answer should be very brief. 0.72. What is the ratio of the ATMs(per 100,000 adults) in Russian Federation in 2009 to that in 2011?
Your answer should be compact. 0.62. What is the ratio of the ATMs(per 100,000 adults) in High income: OECD in 2009 to that in 2012?
Your answer should be compact. 1.01. What is the ratio of the ATMs(per 100,000 adults) in Italy in 2009 to that in 2012?
Your response must be concise. 1.08. What is the ratio of the ATMs(per 100,000 adults) in Mozambique in 2009 to that in 2012?
Ensure brevity in your answer.  0.67. What is the ratio of the ATMs(per 100,000 adults) in Russian Federation in 2009 to that in 2012?
Provide a short and direct response. 0.51. What is the ratio of the ATMs(per 100,000 adults) in High income: OECD in 2009 to that in 2013?
Offer a very short reply. 1.03. What is the ratio of the ATMs(per 100,000 adults) of Italy in 2009 to that in 2013?
Provide a succinct answer. 1.15. What is the ratio of the ATMs(per 100,000 adults) of Mozambique in 2009 to that in 2013?
Your answer should be compact. 0.6. What is the ratio of the ATMs(per 100,000 adults) of Russian Federation in 2009 to that in 2013?
Provide a succinct answer. 0.46. What is the ratio of the ATMs(per 100,000 adults) in High income: OECD in 2009 to that in 2014?
Your answer should be very brief. 1.12. What is the ratio of the ATMs(per 100,000 adults) in Italy in 2009 to that in 2014?
Your response must be concise. 1.16. What is the ratio of the ATMs(per 100,000 adults) in Mozambique in 2009 to that in 2014?
Keep it short and to the point. 0.5. What is the ratio of the ATMs(per 100,000 adults) in Russian Federation in 2009 to that in 2014?
Provide a short and direct response. 0.39. What is the ratio of the ATMs(per 100,000 adults) in High income: OECD in 2010 to that in 2011?
Give a very brief answer. 0.98. What is the ratio of the ATMs(per 100,000 adults) of Italy in 2010 to that in 2011?
Your answer should be compact. 0.98. What is the ratio of the ATMs(per 100,000 adults) of Mozambique in 2010 to that in 2011?
Your response must be concise. 0.88. What is the ratio of the ATMs(per 100,000 adults) of Russian Federation in 2010 to that in 2011?
Provide a succinct answer. 0.82. What is the ratio of the ATMs(per 100,000 adults) of High income: OECD in 2010 to that in 2012?
Offer a terse response. 0.97. What is the ratio of the ATMs(per 100,000 adults) of Italy in 2010 to that in 2012?
Your answer should be very brief. 1.01. What is the ratio of the ATMs(per 100,000 adults) in Mozambique in 2010 to that in 2012?
Keep it short and to the point. 0.81. What is the ratio of the ATMs(per 100,000 adults) in Russian Federation in 2010 to that in 2012?
Your response must be concise. 0.67. What is the ratio of the ATMs(per 100,000 adults) in High income: OECD in 2010 to that in 2013?
Your answer should be compact. 0.99. What is the ratio of the ATMs(per 100,000 adults) in Italy in 2010 to that in 2013?
Ensure brevity in your answer.  1.08. What is the ratio of the ATMs(per 100,000 adults) of Mozambique in 2010 to that in 2013?
Ensure brevity in your answer.  0.73. What is the ratio of the ATMs(per 100,000 adults) in Russian Federation in 2010 to that in 2013?
Your answer should be very brief. 0.61. What is the ratio of the ATMs(per 100,000 adults) in High income: OECD in 2010 to that in 2014?
Give a very brief answer. 1.08. What is the ratio of the ATMs(per 100,000 adults) of Italy in 2010 to that in 2014?
Ensure brevity in your answer.  1.09. What is the ratio of the ATMs(per 100,000 adults) of Mozambique in 2010 to that in 2014?
Offer a very short reply. 0.61. What is the ratio of the ATMs(per 100,000 adults) of Russian Federation in 2010 to that in 2014?
Provide a short and direct response. 0.52. What is the ratio of the ATMs(per 100,000 adults) of Italy in 2011 to that in 2012?
Your answer should be very brief. 1.02. What is the ratio of the ATMs(per 100,000 adults) in Mozambique in 2011 to that in 2012?
Make the answer very short. 0.92. What is the ratio of the ATMs(per 100,000 adults) of Russian Federation in 2011 to that in 2012?
Offer a very short reply. 0.82. What is the ratio of the ATMs(per 100,000 adults) in High income: OECD in 2011 to that in 2013?
Give a very brief answer. 1.01. What is the ratio of the ATMs(per 100,000 adults) in Italy in 2011 to that in 2013?
Ensure brevity in your answer.  1.1. What is the ratio of the ATMs(per 100,000 adults) of Mozambique in 2011 to that in 2013?
Your answer should be very brief. 0.83. What is the ratio of the ATMs(per 100,000 adults) in Russian Federation in 2011 to that in 2013?
Keep it short and to the point. 0.75. What is the ratio of the ATMs(per 100,000 adults) of High income: OECD in 2011 to that in 2014?
Provide a short and direct response. 1.1. What is the ratio of the ATMs(per 100,000 adults) in Italy in 2011 to that in 2014?
Your response must be concise. 1.11. What is the ratio of the ATMs(per 100,000 adults) in Mozambique in 2011 to that in 2014?
Make the answer very short. 0.7. What is the ratio of the ATMs(per 100,000 adults) of Russian Federation in 2011 to that in 2014?
Provide a succinct answer. 0.63. What is the ratio of the ATMs(per 100,000 adults) in High income: OECD in 2012 to that in 2013?
Keep it short and to the point. 1.01. What is the ratio of the ATMs(per 100,000 adults) of Italy in 2012 to that in 2013?
Keep it short and to the point. 1.07. What is the ratio of the ATMs(per 100,000 adults) of Mozambique in 2012 to that in 2013?
Your answer should be compact. 0.9. What is the ratio of the ATMs(per 100,000 adults) of Russian Federation in 2012 to that in 2013?
Your answer should be compact. 0.91. What is the ratio of the ATMs(per 100,000 adults) of High income: OECD in 2012 to that in 2014?
Provide a succinct answer. 1.11. What is the ratio of the ATMs(per 100,000 adults) of Italy in 2012 to that in 2014?
Ensure brevity in your answer.  1.08. What is the ratio of the ATMs(per 100,000 adults) of Mozambique in 2012 to that in 2014?
Make the answer very short. 0.76. What is the ratio of the ATMs(per 100,000 adults) of Russian Federation in 2012 to that in 2014?
Your response must be concise. 0.77. What is the ratio of the ATMs(per 100,000 adults) of High income: OECD in 2013 to that in 2014?
Offer a very short reply. 1.09. What is the ratio of the ATMs(per 100,000 adults) in Italy in 2013 to that in 2014?
Your answer should be very brief. 1.01. What is the ratio of the ATMs(per 100,000 adults) of Mozambique in 2013 to that in 2014?
Keep it short and to the point. 0.84. What is the ratio of the ATMs(per 100,000 adults) in Russian Federation in 2013 to that in 2014?
Offer a very short reply. 0.85. What is the difference between the highest and the second highest ATMs(per 100,000 adults) of High income: OECD?
Your answer should be compact. 1.06. What is the difference between the highest and the second highest ATMs(per 100,000 adults) of Italy?
Keep it short and to the point. 5.3. What is the difference between the highest and the second highest ATMs(per 100,000 adults) of Mozambique?
Give a very brief answer. 1.47. What is the difference between the highest and the second highest ATMs(per 100,000 adults) in Russian Federation?
Ensure brevity in your answer.  28.48. What is the difference between the highest and the lowest ATMs(per 100,000 adults) in High income: OECD?
Keep it short and to the point. 10.18. What is the difference between the highest and the lowest ATMs(per 100,000 adults) in Italy?
Keep it short and to the point. 19.59. What is the difference between the highest and the lowest ATMs(per 100,000 adults) in Mozambique?
Make the answer very short. 5.57. What is the difference between the highest and the lowest ATMs(per 100,000 adults) of Russian Federation?
Provide a succinct answer. 139.69. 